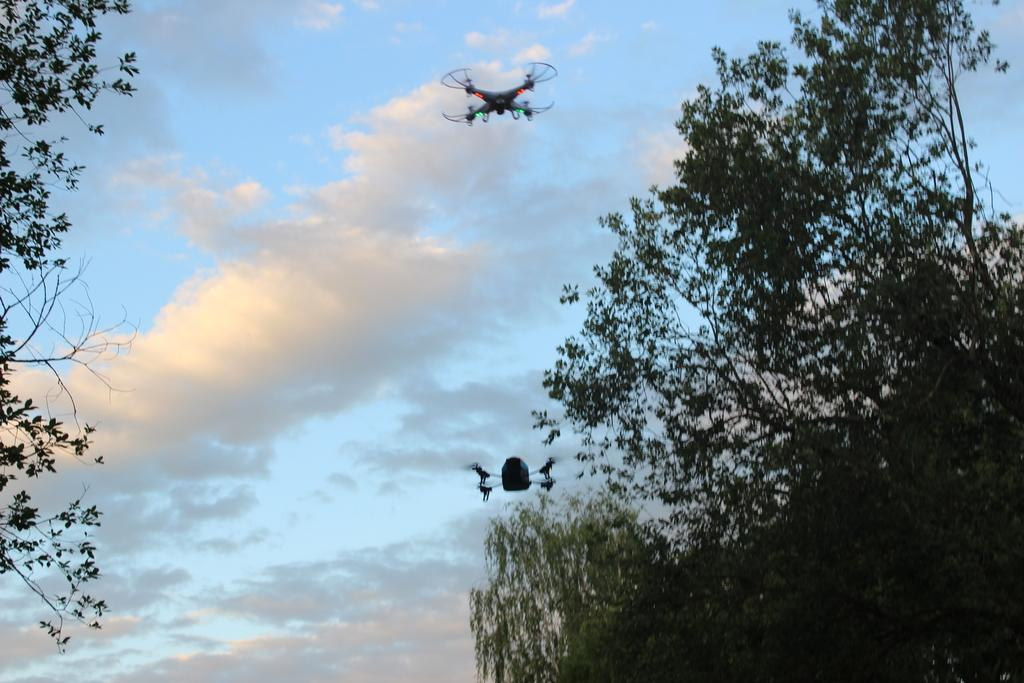What type of vegetation can be seen in the image? There are trees in the image. What color are the trees? The trees are green. What are the two objects flying in the image? There are two drones in the image. What is visible in the background of the image? The sky is visible in the background of the image. What colors can be seen in the sky? The sky is blue and white in color. What type of skin condition can be seen on the trees in the image? There is no mention of any skin condition on the trees in the image; they are simply green. Is there a hill visible in the image? There is no hill mentioned or visible in the image; it features trees, drones, and a blue and white sky. 